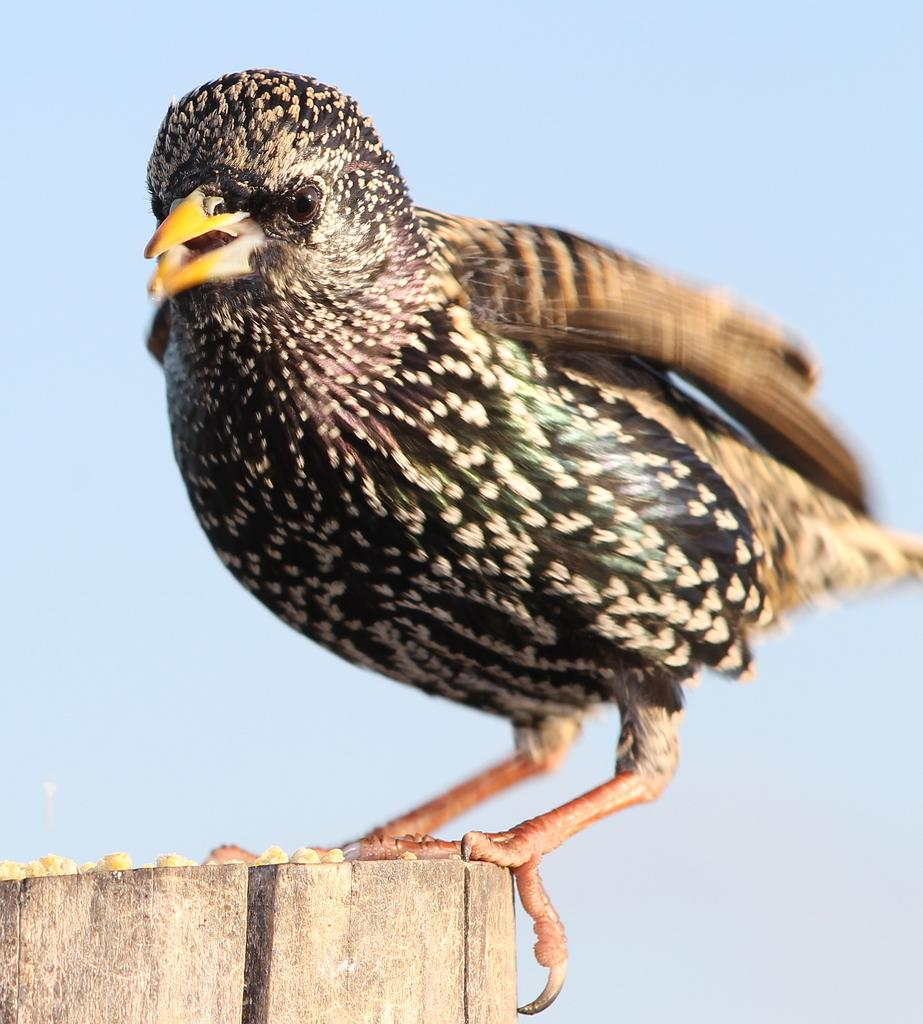What type of animal can be seen in the image? There is a bird in the image. What is the bird standing on? The bird is standing on a piece of wood. What type of oil is being used by the bird in the image? There is no oil present in the image, and the bird is not using any oil. 